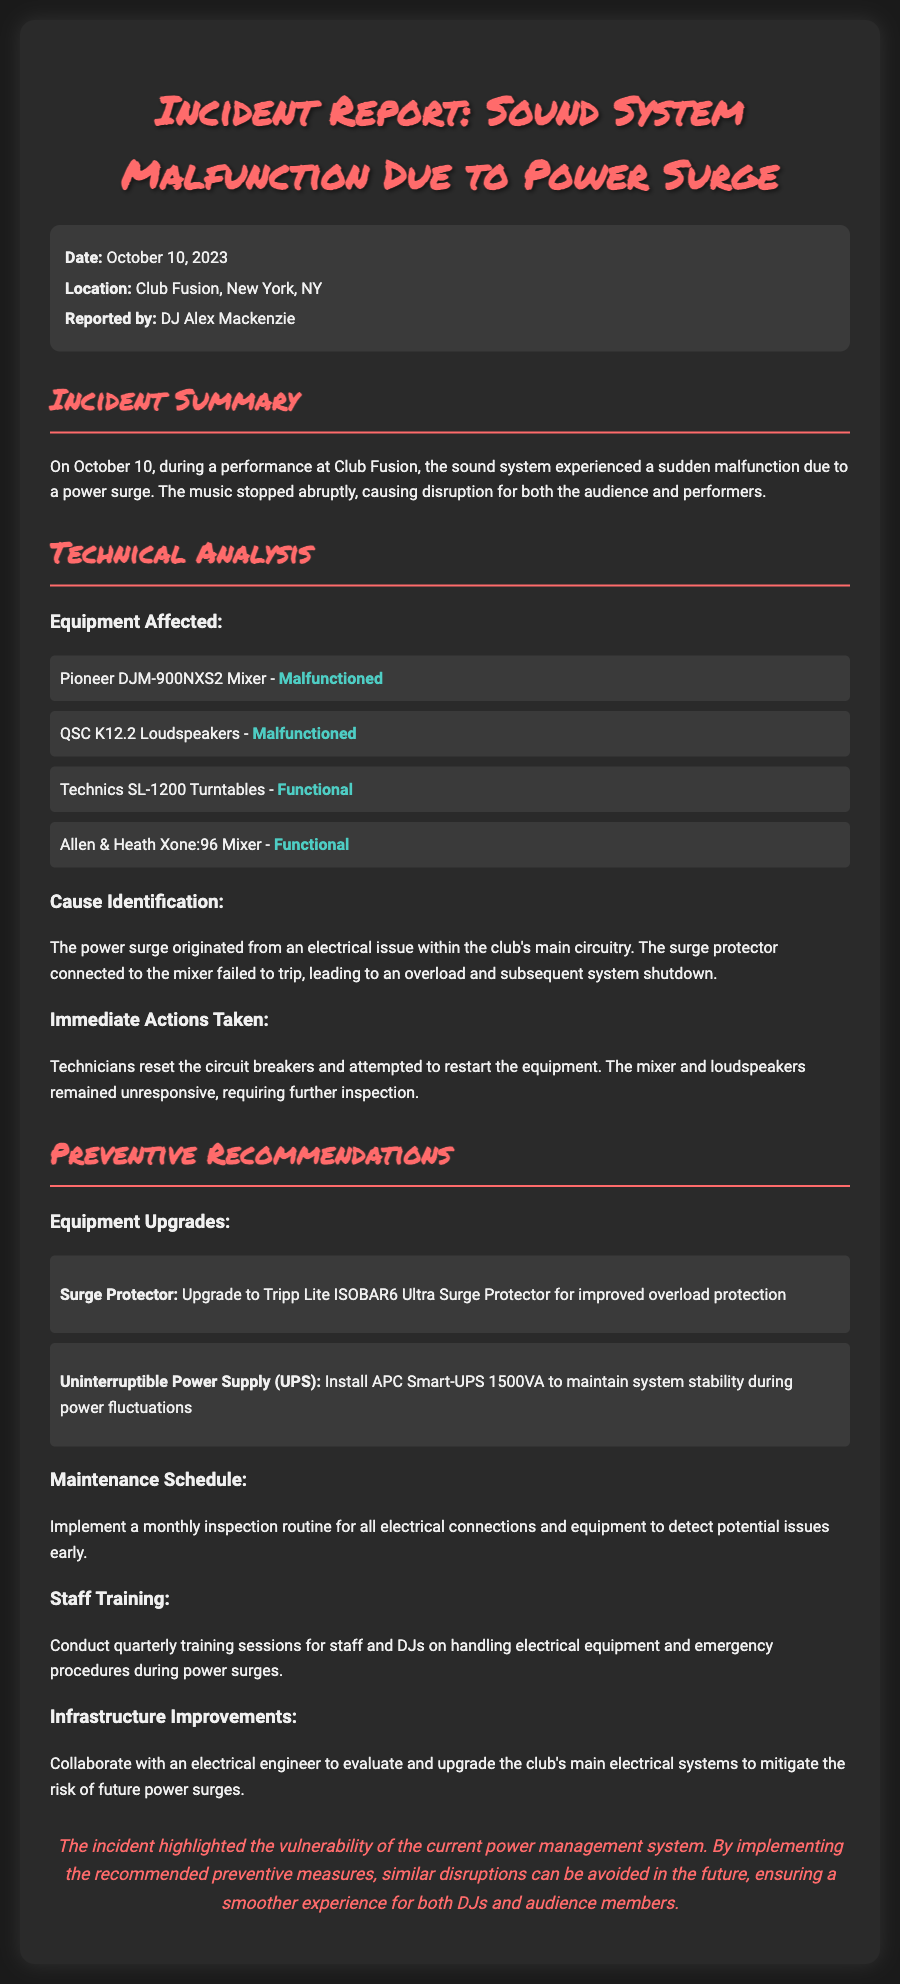What is the date of the incident? The incident occurred on October 10, 2023, as stated in the document.
Answer: October 10, 2023 Where did the incident take place? The location of the incident is specified as Club Fusion, New York, NY.
Answer: Club Fusion, New York, NY Who reported the incident? The report mentions that DJ Alex Mackenzie is the person who reported the incident.
Answer: DJ Alex Mackenzie Which equipment malfunctioned during the incident? The document indicates that the Pioneer DJM-900NXS2 Mixer and QSC K12.2 Loudspeakers malfunctioned.
Answer: Pioneer DJM-900NXS2 Mixer, QSC K12.2 Loudspeakers What caused the power surge? The cause of the power surge was identified as an electrical issue within the club's main circuitry.
Answer: Electrical issue within the club's main circuitry What is one recommendation for equipment upgrades? The report recommends upgrading to a Tripp Lite ISOBAR6 Ultra Surge Protector for improved overload protection.
Answer: Tripp Lite ISOBAR6 Ultra Surge Protector How often should maintenance inspections be conducted? The document suggests implementing a monthly inspection routine for all electrical connections and equipment.
Answer: Monthly What training is recommended for staff? The report recommends conducting quarterly training sessions for staff and DJs on handling electrical equipment.
Answer: Quarterly training sessions What is the conclusion regarding the incident? The conclusion highlights the vulnerability of the current power management system and suggests that recommended measures can prevent future disruptions.
Answer: Vulnerability of the current power management system 